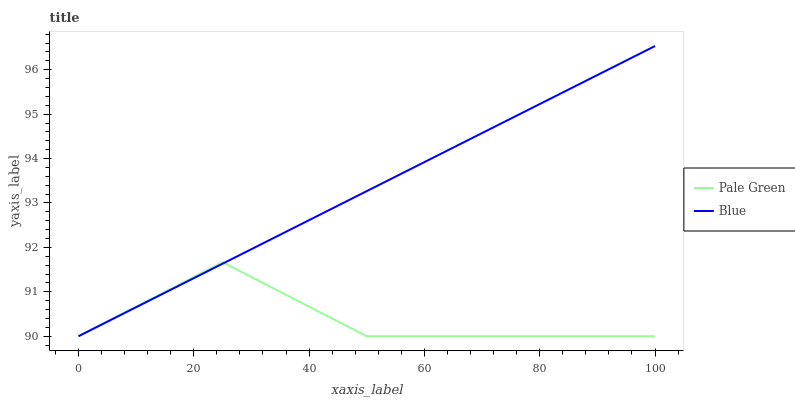Does Pale Green have the minimum area under the curve?
Answer yes or no. Yes. Does Blue have the maximum area under the curve?
Answer yes or no. Yes. Does Pale Green have the maximum area under the curve?
Answer yes or no. No. Is Blue the smoothest?
Answer yes or no. Yes. Is Pale Green the roughest?
Answer yes or no. Yes. Is Pale Green the smoothest?
Answer yes or no. No. Does Blue have the lowest value?
Answer yes or no. Yes. Does Blue have the highest value?
Answer yes or no. Yes. Does Pale Green have the highest value?
Answer yes or no. No. Does Blue intersect Pale Green?
Answer yes or no. Yes. Is Blue less than Pale Green?
Answer yes or no. No. Is Blue greater than Pale Green?
Answer yes or no. No. 